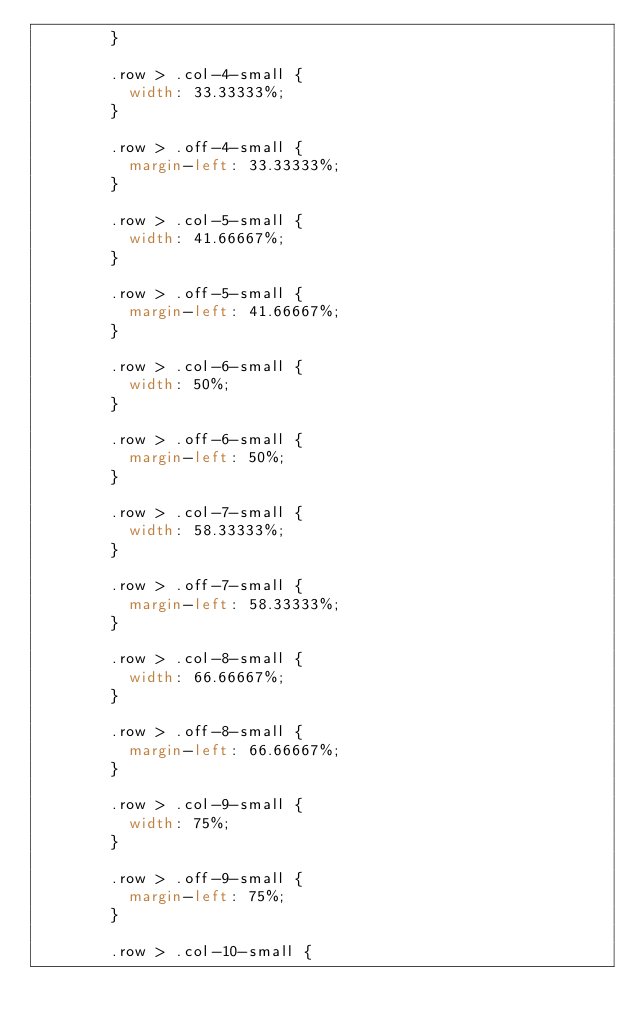Convert code to text. <code><loc_0><loc_0><loc_500><loc_500><_CSS_>				}

				.row > .col-4-small {
					width: 33.33333%;
				}

				.row > .off-4-small {
					margin-left: 33.33333%;
				}

				.row > .col-5-small {
					width: 41.66667%;
				}

				.row > .off-5-small {
					margin-left: 41.66667%;
				}

				.row > .col-6-small {
					width: 50%;
				}

				.row > .off-6-small {
					margin-left: 50%;
				}

				.row > .col-7-small {
					width: 58.33333%;
				}

				.row > .off-7-small {
					margin-left: 58.33333%;
				}

				.row > .col-8-small {
					width: 66.66667%;
				}

				.row > .off-8-small {
					margin-left: 66.66667%;
				}

				.row > .col-9-small {
					width: 75%;
				}

				.row > .off-9-small {
					margin-left: 75%;
				}

				.row > .col-10-small {</code> 